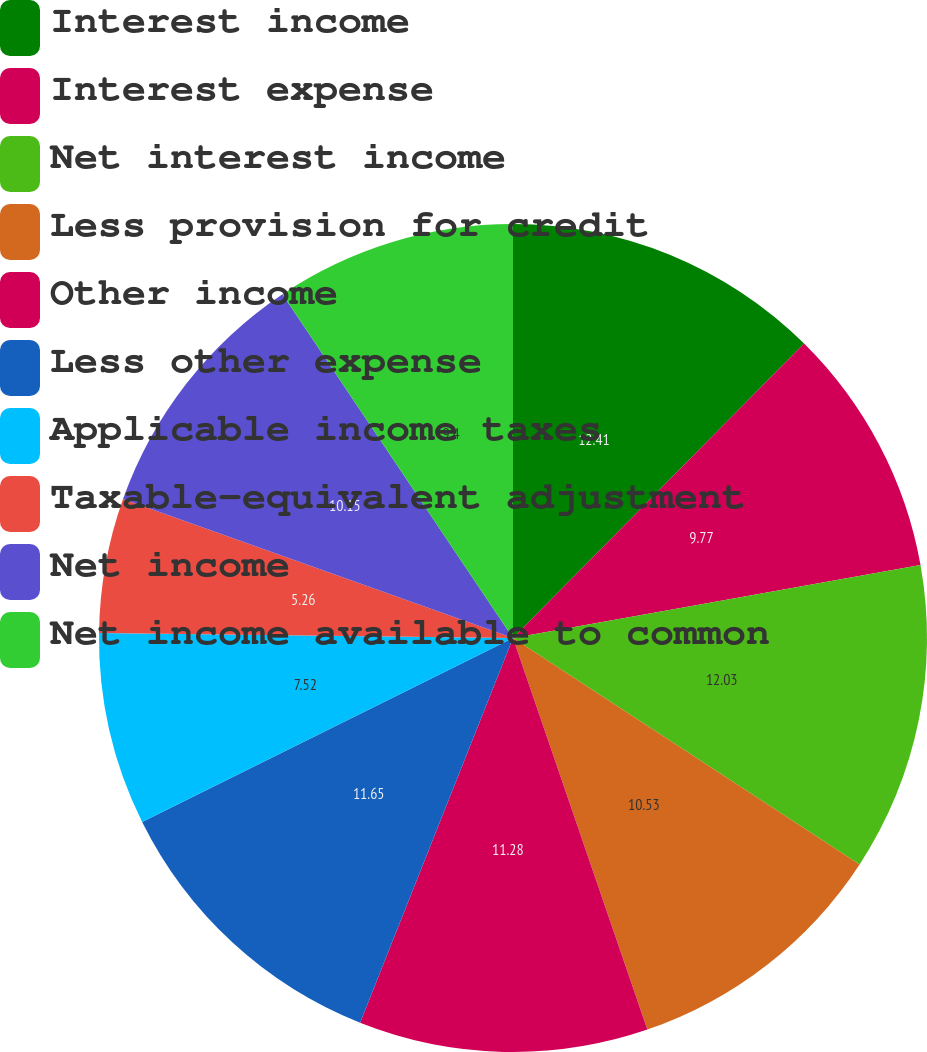Convert chart. <chart><loc_0><loc_0><loc_500><loc_500><pie_chart><fcel>Interest income<fcel>Interest expense<fcel>Net interest income<fcel>Less provision for credit<fcel>Other income<fcel>Less other expense<fcel>Applicable income taxes<fcel>Taxable-equivalent adjustment<fcel>Net income<fcel>Net income available to common<nl><fcel>12.41%<fcel>9.77%<fcel>12.03%<fcel>10.53%<fcel>11.28%<fcel>11.65%<fcel>7.52%<fcel>5.26%<fcel>10.15%<fcel>9.4%<nl></chart> 